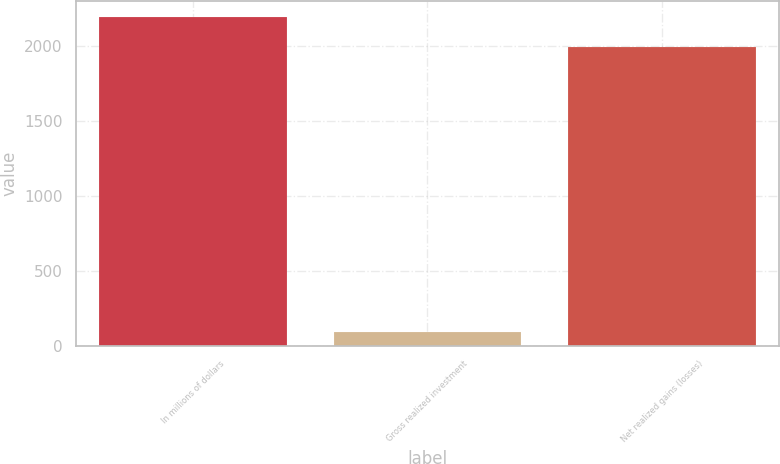<chart> <loc_0><loc_0><loc_500><loc_500><bar_chart><fcel>In millions of dollars<fcel>Gross realized investment<fcel>Net realized gains (losses)<nl><fcel>2195.6<fcel>94<fcel>1996<nl></chart> 